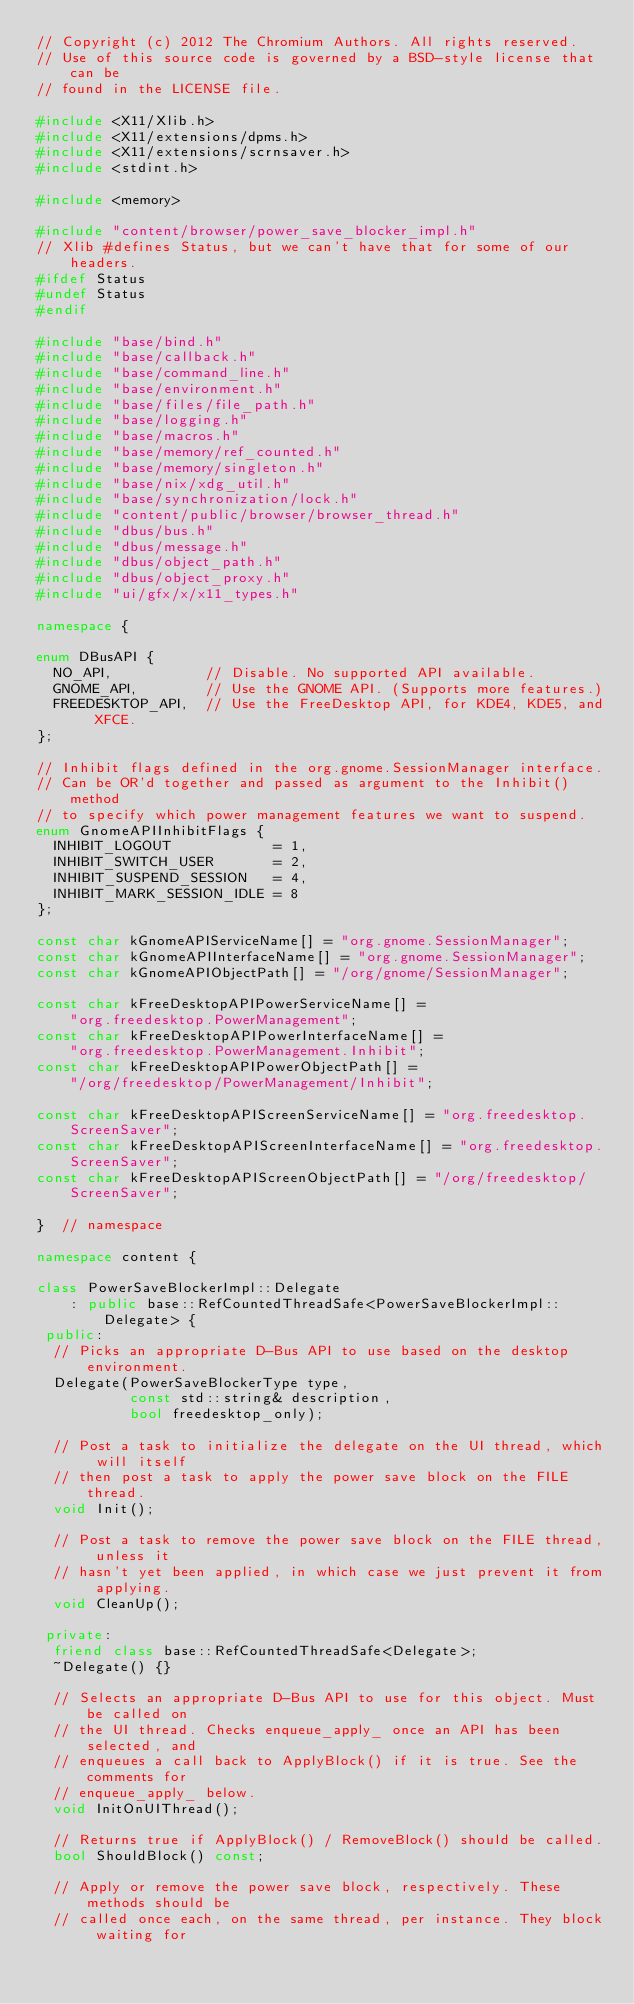Convert code to text. <code><loc_0><loc_0><loc_500><loc_500><_C++_>// Copyright (c) 2012 The Chromium Authors. All rights reserved.
// Use of this source code is governed by a BSD-style license that can be
// found in the LICENSE file.

#include <X11/Xlib.h>
#include <X11/extensions/dpms.h>
#include <X11/extensions/scrnsaver.h>
#include <stdint.h>

#include <memory>

#include "content/browser/power_save_blocker_impl.h"
// Xlib #defines Status, but we can't have that for some of our headers.
#ifdef Status
#undef Status
#endif

#include "base/bind.h"
#include "base/callback.h"
#include "base/command_line.h"
#include "base/environment.h"
#include "base/files/file_path.h"
#include "base/logging.h"
#include "base/macros.h"
#include "base/memory/ref_counted.h"
#include "base/memory/singleton.h"
#include "base/nix/xdg_util.h"
#include "base/synchronization/lock.h"
#include "content/public/browser/browser_thread.h"
#include "dbus/bus.h"
#include "dbus/message.h"
#include "dbus/object_path.h"
#include "dbus/object_proxy.h"
#include "ui/gfx/x/x11_types.h"

namespace {

enum DBusAPI {
  NO_API,           // Disable. No supported API available.
  GNOME_API,        // Use the GNOME API. (Supports more features.)
  FREEDESKTOP_API,  // Use the FreeDesktop API, for KDE4, KDE5, and XFCE.
};

// Inhibit flags defined in the org.gnome.SessionManager interface.
// Can be OR'd together and passed as argument to the Inhibit() method
// to specify which power management features we want to suspend.
enum GnomeAPIInhibitFlags {
  INHIBIT_LOGOUT            = 1,
  INHIBIT_SWITCH_USER       = 2,
  INHIBIT_SUSPEND_SESSION   = 4,
  INHIBIT_MARK_SESSION_IDLE = 8
};

const char kGnomeAPIServiceName[] = "org.gnome.SessionManager";
const char kGnomeAPIInterfaceName[] = "org.gnome.SessionManager";
const char kGnomeAPIObjectPath[] = "/org/gnome/SessionManager";

const char kFreeDesktopAPIPowerServiceName[] =
    "org.freedesktop.PowerManagement";
const char kFreeDesktopAPIPowerInterfaceName[] =
    "org.freedesktop.PowerManagement.Inhibit";
const char kFreeDesktopAPIPowerObjectPath[] =
    "/org/freedesktop/PowerManagement/Inhibit";

const char kFreeDesktopAPIScreenServiceName[] = "org.freedesktop.ScreenSaver";
const char kFreeDesktopAPIScreenInterfaceName[] = "org.freedesktop.ScreenSaver";
const char kFreeDesktopAPIScreenObjectPath[] = "/org/freedesktop/ScreenSaver";

}  // namespace

namespace content {

class PowerSaveBlockerImpl::Delegate
    : public base::RefCountedThreadSafe<PowerSaveBlockerImpl::Delegate> {
 public:
  // Picks an appropriate D-Bus API to use based on the desktop environment.
  Delegate(PowerSaveBlockerType type,
           const std::string& description,
           bool freedesktop_only);

  // Post a task to initialize the delegate on the UI thread, which will itself
  // then post a task to apply the power save block on the FILE thread.
  void Init();

  // Post a task to remove the power save block on the FILE thread, unless it
  // hasn't yet been applied, in which case we just prevent it from applying.
  void CleanUp();

 private:
  friend class base::RefCountedThreadSafe<Delegate>;
  ~Delegate() {}

  // Selects an appropriate D-Bus API to use for this object. Must be called on
  // the UI thread. Checks enqueue_apply_ once an API has been selected, and
  // enqueues a call back to ApplyBlock() if it is true. See the comments for
  // enqueue_apply_ below.
  void InitOnUIThread();

  // Returns true if ApplyBlock() / RemoveBlock() should be called.
  bool ShouldBlock() const;

  // Apply or remove the power save block, respectively. These methods should be
  // called once each, on the same thread, per instance. They block waiting for</code> 